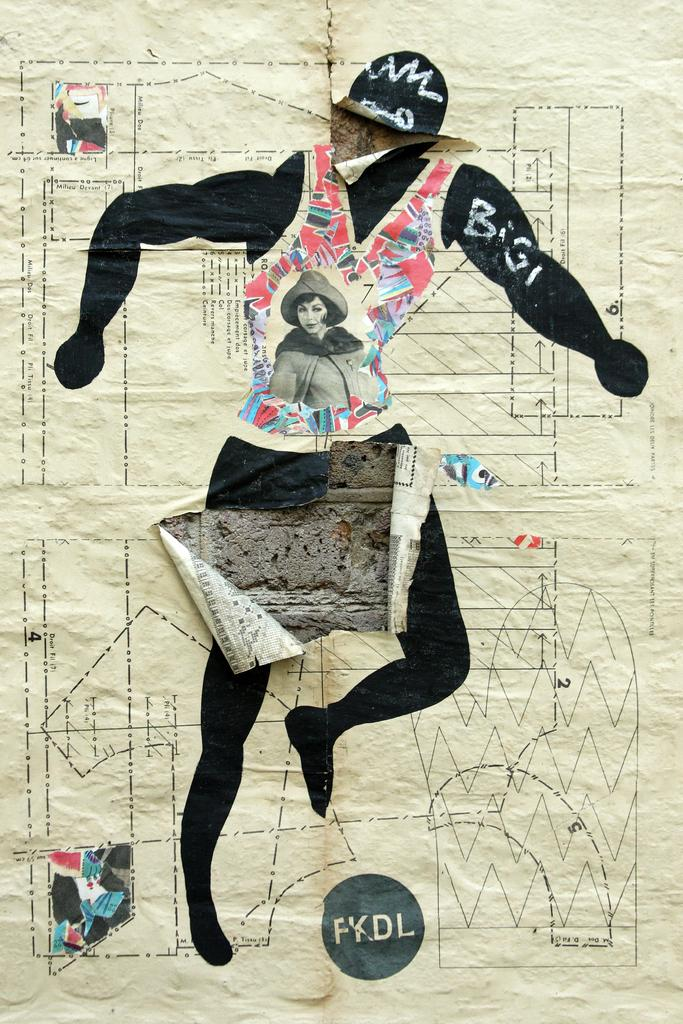What is depicted on the paper in the image? There is a person's image on the paper. What can be seen behind the paper in the image? The paper is attached to a grey color wall. Is there a stove visible in the image? No, there is no stove present in the image. 